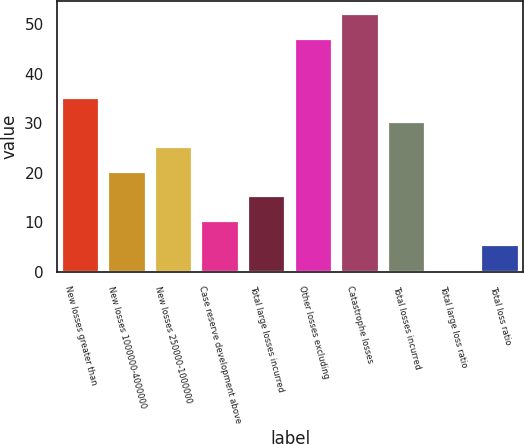Convert chart. <chart><loc_0><loc_0><loc_500><loc_500><bar_chart><fcel>New losses greater than<fcel>New losses 1000000-4000000<fcel>New losses 250000-1000000<fcel>Case reserve development above<fcel>Total large losses incurred<fcel>Other losses excluding<fcel>Catastrophe losses<fcel>Total losses incurred<fcel>Total large loss ratio<fcel>Total loss ratio<nl><fcel>35.09<fcel>20.18<fcel>25.15<fcel>10.24<fcel>15.21<fcel>47<fcel>51.97<fcel>30.12<fcel>0.3<fcel>5.27<nl></chart> 